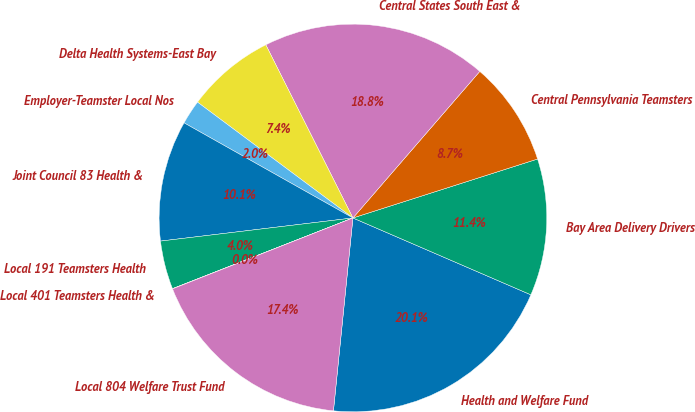Convert chart. <chart><loc_0><loc_0><loc_500><loc_500><pie_chart><fcel>Health and Welfare Fund<fcel>Bay Area Delivery Drivers<fcel>Central Pennsylvania Teamsters<fcel>Central States South East &<fcel>Delta Health Systems-East Bay<fcel>Employer-Teamster Local Nos<fcel>Joint Council 83 Health &<fcel>Local 191 Teamsters Health<fcel>Local 401 Teamsters Health &<fcel>Local 804 Welfare Trust Fund<nl><fcel>20.12%<fcel>11.41%<fcel>8.73%<fcel>18.78%<fcel>7.39%<fcel>2.03%<fcel>10.07%<fcel>4.04%<fcel>0.02%<fcel>17.44%<nl></chart> 